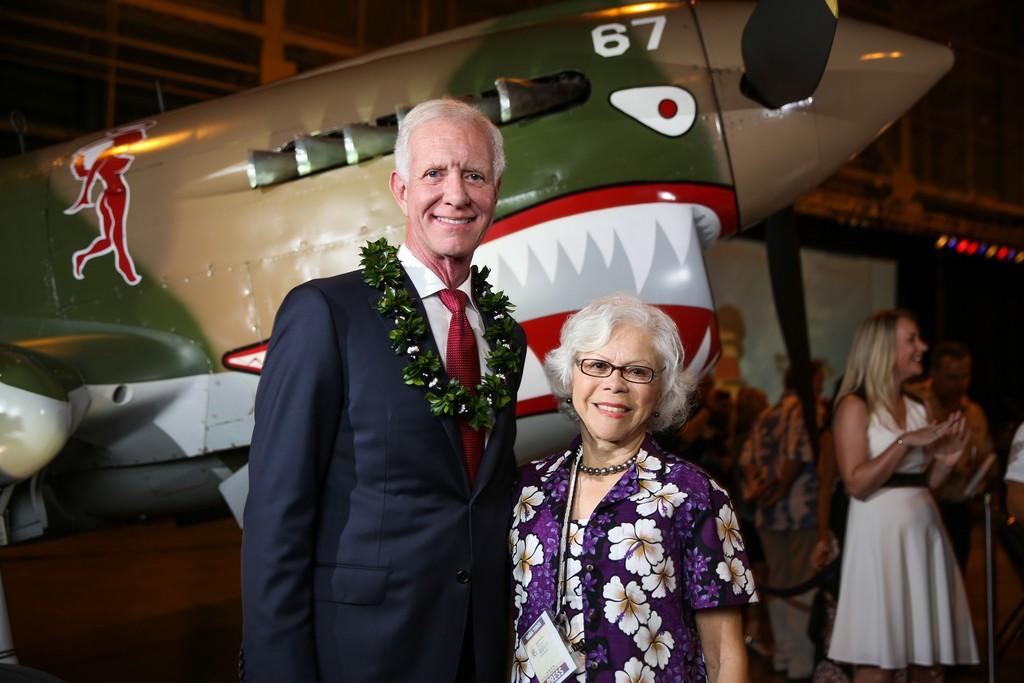<image>
Write a terse but informative summary of the picture. a man in a suit and a woman with a white flowered shirt standing in front of a plane with the number 67 on it. 